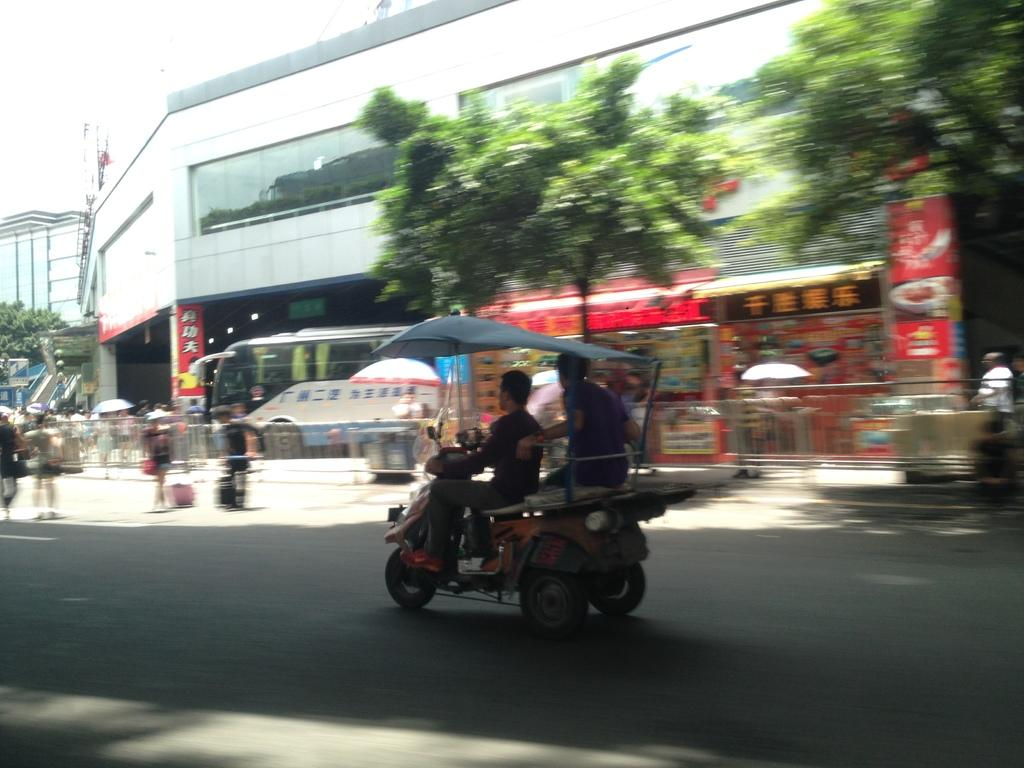How many people are in the vehicle in the image? There are two persons riding in the vehicle in the image. Where is the vehicle located? The vehicle is on the road in the image. What can be seen in the background of the image? There are big buildings and trees in the image. Are there any other vehicles in the image? Yes, there are other vehicles in the image. What else can be seen on the road in the image? There are people on the road in the image. What type of science experiment is being conducted on the road in the image? There is no science experiment visible in the image; it features a vehicle with two persons inside and other elements mentioned earlier. Can you tell me how many blades are attached to the vehicle in the image? There are no blades attached to the vehicle in the image. 